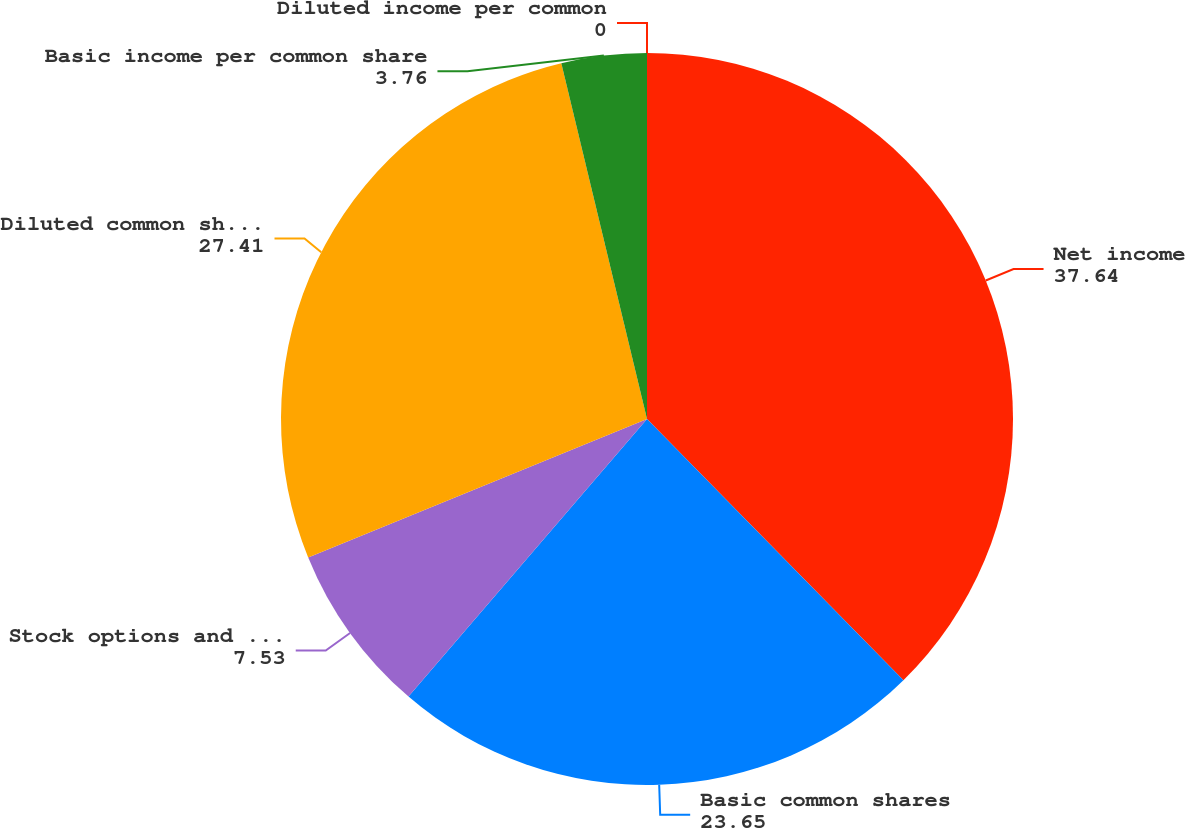Convert chart to OTSL. <chart><loc_0><loc_0><loc_500><loc_500><pie_chart><fcel>Net income<fcel>Basic common shares<fcel>Stock options and unvested<fcel>Diluted common shares<fcel>Basic income per common share<fcel>Diluted income per common<nl><fcel>37.64%<fcel>23.65%<fcel>7.53%<fcel>27.41%<fcel>3.76%<fcel>0.0%<nl></chart> 